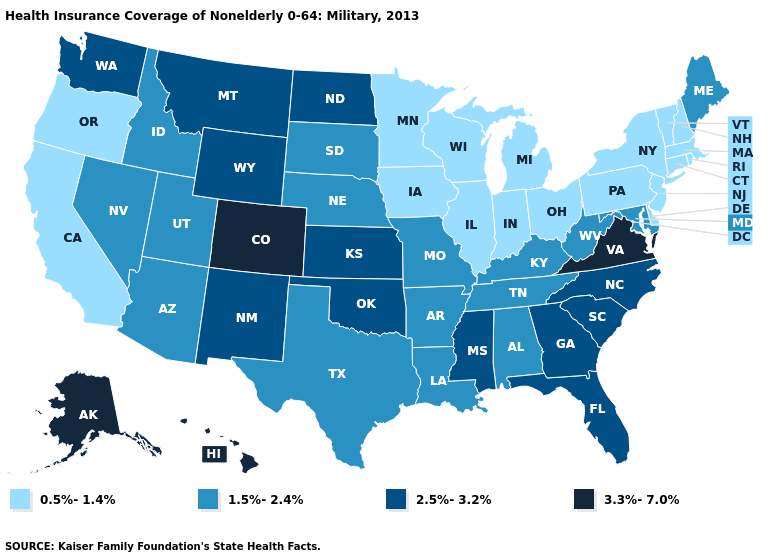Does Rhode Island have a lower value than Iowa?
Short answer required. No. What is the lowest value in states that border Kansas?
Be succinct. 1.5%-2.4%. What is the lowest value in the USA?
Keep it brief. 0.5%-1.4%. What is the lowest value in the MidWest?
Short answer required. 0.5%-1.4%. What is the lowest value in states that border Colorado?
Keep it brief. 1.5%-2.4%. Name the states that have a value in the range 0.5%-1.4%?
Give a very brief answer. California, Connecticut, Delaware, Illinois, Indiana, Iowa, Massachusetts, Michigan, Minnesota, New Hampshire, New Jersey, New York, Ohio, Oregon, Pennsylvania, Rhode Island, Vermont, Wisconsin. What is the lowest value in the MidWest?
Short answer required. 0.5%-1.4%. Does Arkansas have the lowest value in the USA?
Give a very brief answer. No. Name the states that have a value in the range 3.3%-7.0%?
Keep it brief. Alaska, Colorado, Hawaii, Virginia. Does the first symbol in the legend represent the smallest category?
Be succinct. Yes. Is the legend a continuous bar?
Keep it brief. No. Does New York have the lowest value in the USA?
Give a very brief answer. Yes. Name the states that have a value in the range 3.3%-7.0%?
Answer briefly. Alaska, Colorado, Hawaii, Virginia. What is the lowest value in the USA?
Short answer required. 0.5%-1.4%. 